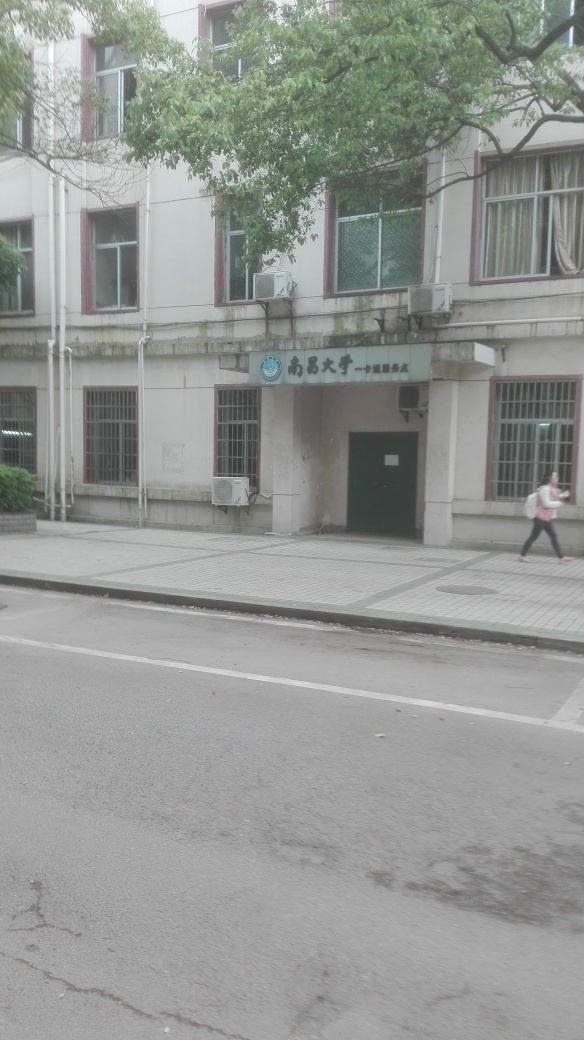What is the weather like in the image? The weather appears to be overcast, as the sky is quite gray and there are no distinct shadows visible on the ground. This suggests that there may be cloud cover diffusing the sunlight. 